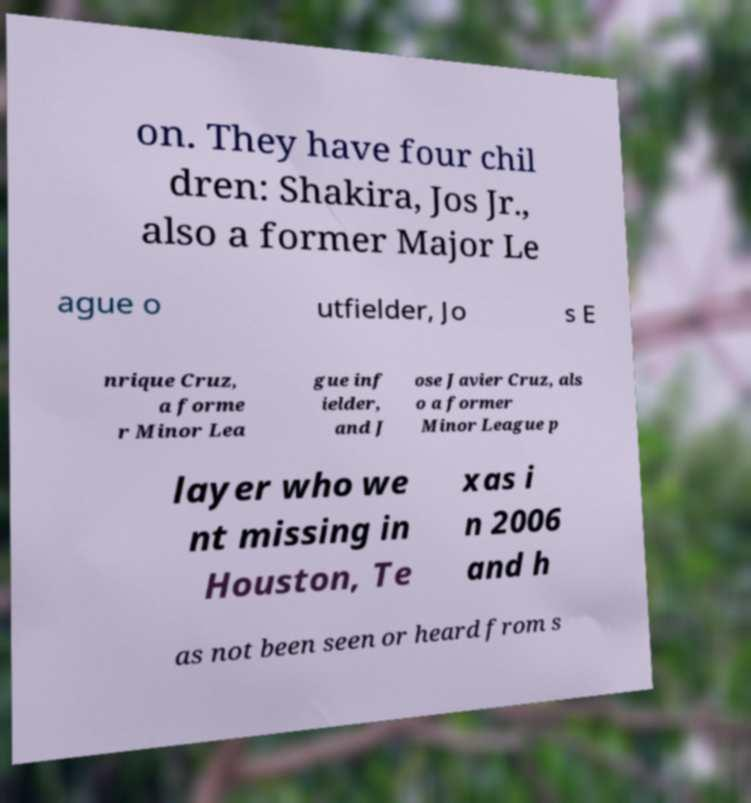Please read and relay the text visible in this image. What does it say? on. They have four chil dren: Shakira, Jos Jr., also a former Major Le ague o utfielder, Jo s E nrique Cruz, a forme r Minor Lea gue inf ielder, and J ose Javier Cruz, als o a former Minor League p layer who we nt missing in Houston, Te xas i n 2006 and h as not been seen or heard from s 